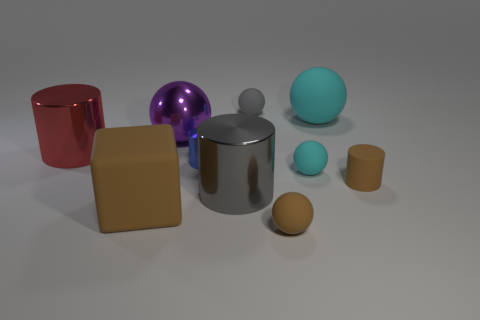There is a matte cylinder that is the same size as the blue metallic object; what is its color?
Offer a very short reply. Brown. What number of small brown objects are the same shape as the large red thing?
Provide a short and direct response. 1. Do the purple ball and the brown object behind the gray shiny cylinder have the same size?
Your answer should be very brief. No. The red metallic thing that is on the left side of the large object that is behind the purple thing is what shape?
Your answer should be very brief. Cylinder. Is the number of big cyan balls that are in front of the small blue metal thing less than the number of metallic things?
Your answer should be compact. Yes. There is a tiny thing that is the same color as the small matte cylinder; what shape is it?
Offer a terse response. Sphere. How many gray matte things have the same size as the metal ball?
Offer a terse response. 0. There is a tiny thing in front of the large brown matte cube; what shape is it?
Keep it short and to the point. Sphere. Is the number of tiny brown things less than the number of green shiny balls?
Offer a terse response. No. Are there any other things that have the same color as the rubber block?
Offer a terse response. Yes. 